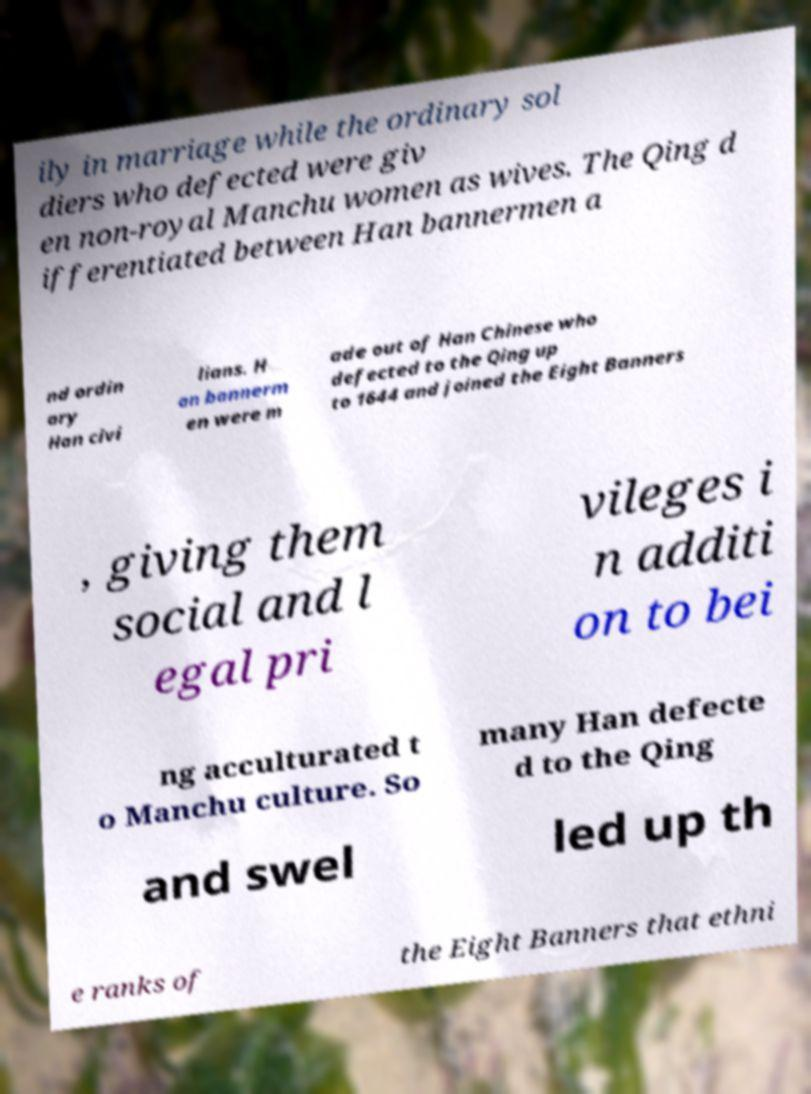Please read and relay the text visible in this image. What does it say? ily in marriage while the ordinary sol diers who defected were giv en non-royal Manchu women as wives. The Qing d ifferentiated between Han bannermen a nd ordin ary Han civi lians. H an bannerm en were m ade out of Han Chinese who defected to the Qing up to 1644 and joined the Eight Banners , giving them social and l egal pri vileges i n additi on to bei ng acculturated t o Manchu culture. So many Han defecte d to the Qing and swel led up th e ranks of the Eight Banners that ethni 